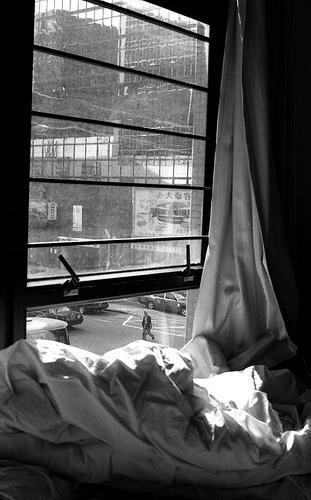How many handles are pointing left?
Give a very brief answer. 0. 